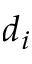Convert formula to latex. <formula><loc_0><loc_0><loc_500><loc_500>d _ { i }</formula> 